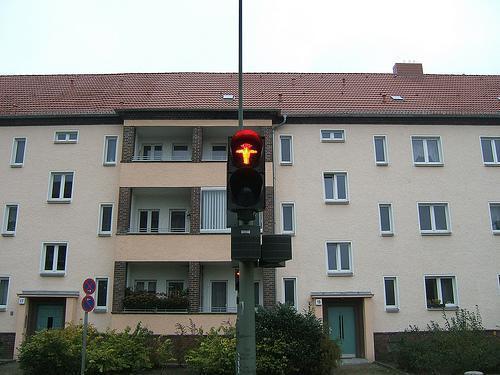How many entryways are there?
Give a very brief answer. 2. How many stories does the building have?
Give a very brief answer. 4. How many floors does the building have?
Give a very brief answer. 3. How many entrances does the building have?
Give a very brief answer. 2. How many traffic lights are in the picture?
Give a very brief answer. 1. How many people are in the picture?
Give a very brief answer. 0. 